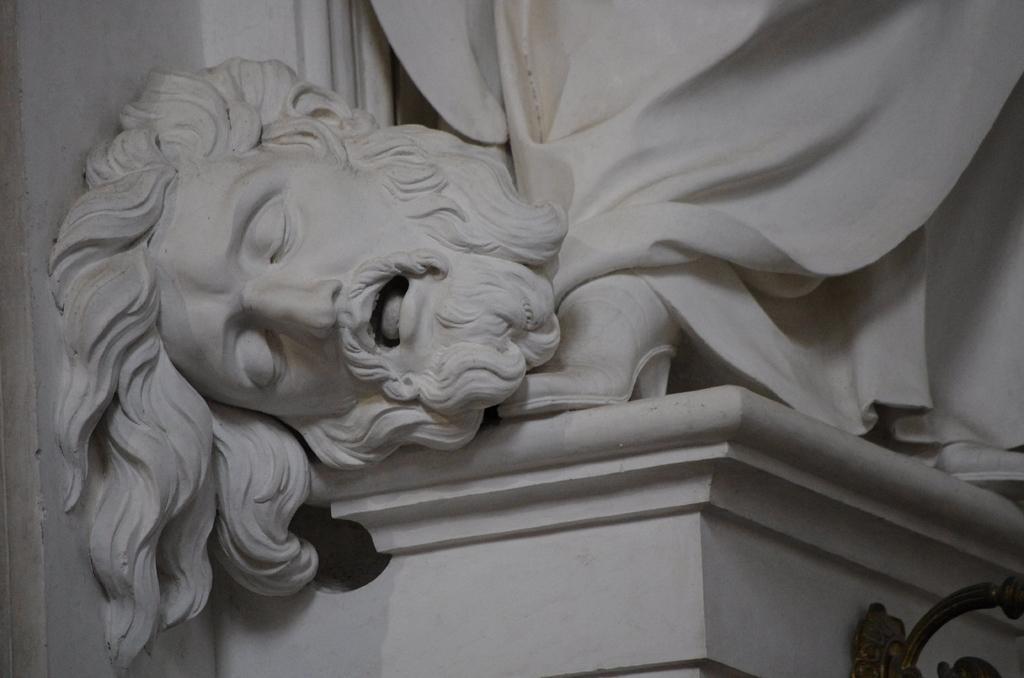In one or two sentences, can you explain what this image depicts? In this image we can see statue of a person's head on a pedestal. Also there is an iron object at the bottom. 